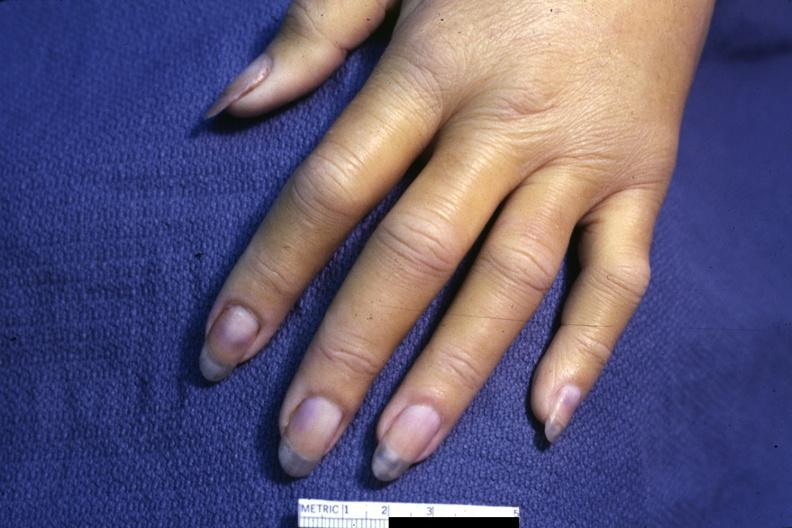s lymphoma present?
Answer the question using a single word or phrase. No 